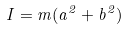<formula> <loc_0><loc_0><loc_500><loc_500>I = m ( a ^ { 2 } + b ^ { 2 } )</formula> 